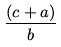<formula> <loc_0><loc_0><loc_500><loc_500>\frac { ( c + a ) } { b }</formula> 